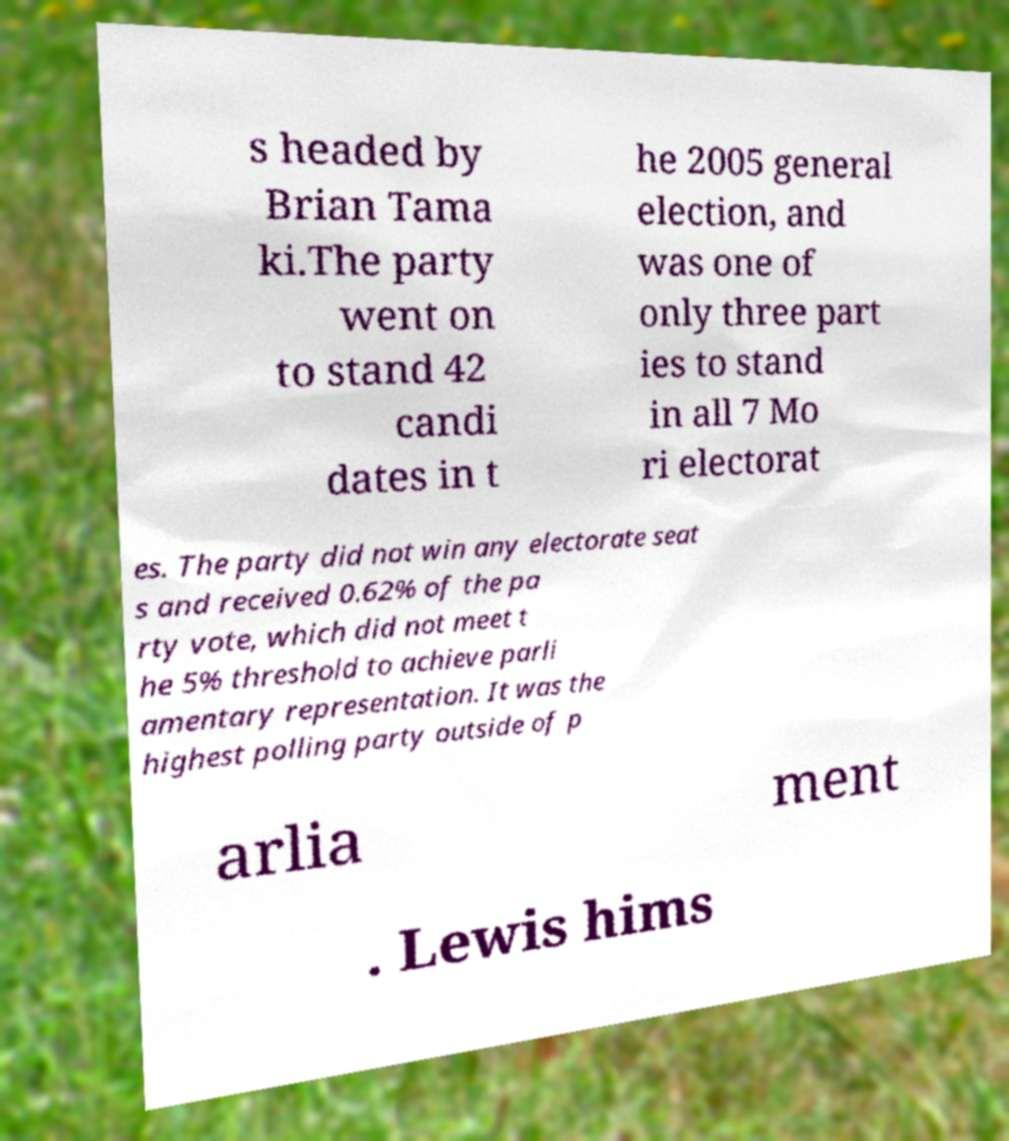Could you extract and type out the text from this image? s headed by Brian Tama ki.The party went on to stand 42 candi dates in t he 2005 general election, and was one of only three part ies to stand in all 7 Mo ri electorat es. The party did not win any electorate seat s and received 0.62% of the pa rty vote, which did not meet t he 5% threshold to achieve parli amentary representation. It was the highest polling party outside of p arlia ment . Lewis hims 